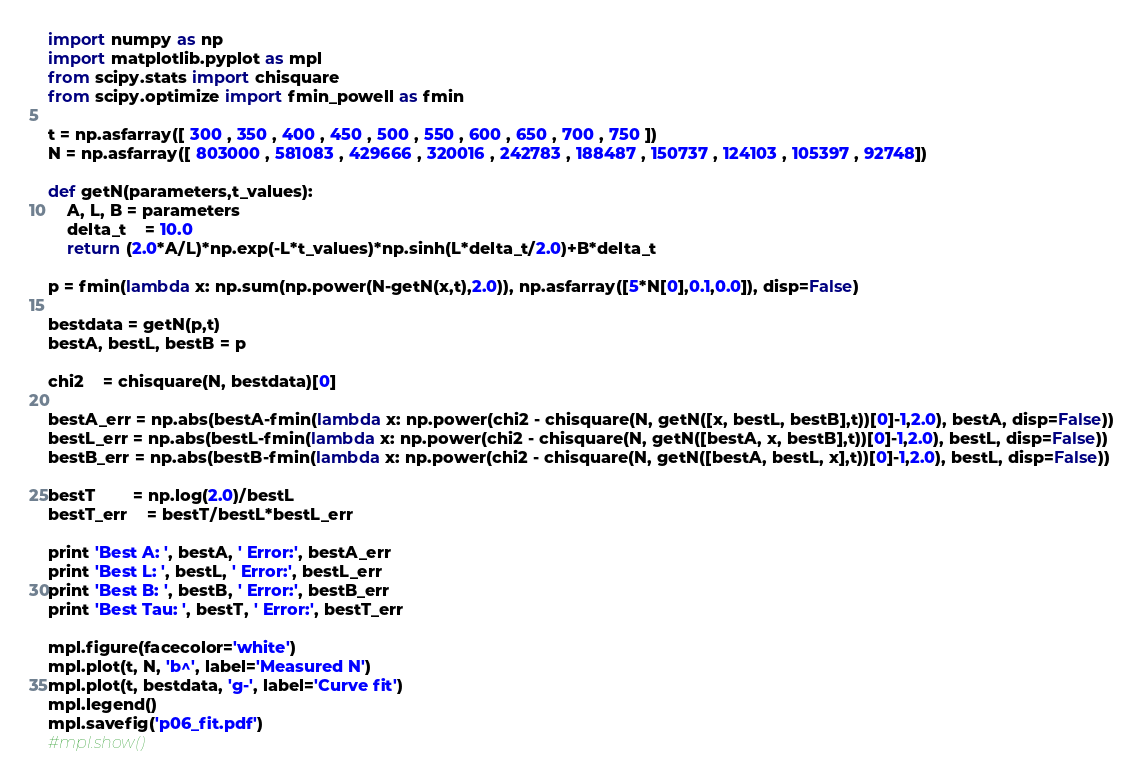<code> <loc_0><loc_0><loc_500><loc_500><_Python_>import numpy as np
import matplotlib.pyplot as mpl
from scipy.stats import chisquare
from scipy.optimize import fmin_powell as fmin

t = np.asfarray([ 300 , 350 , 400 , 450 , 500 , 550 , 600 , 650 , 700 , 750 ])
N = np.asfarray([ 803000 , 581083 , 429666 , 320016 , 242783 , 188487 , 150737 , 124103 , 105397 , 92748])

def getN(parameters,t_values):
	A, L, B = parameters
	delta_t	= 10.0
	return (2.0*A/L)*np.exp(-L*t_values)*np.sinh(L*delta_t/2.0)+B*delta_t

p = fmin(lambda x: np.sum(np.power(N-getN(x,t),2.0)), np.asfarray([5*N[0],0.1,0.0]), disp=False)

bestdata = getN(p,t)
bestA, bestL, bestB = p

chi2	= chisquare(N, bestdata)[0]

bestA_err = np.abs(bestA-fmin(lambda x: np.power(chi2 - chisquare(N, getN([x, bestL, bestB],t))[0]-1,2.0), bestA, disp=False))
bestL_err = np.abs(bestL-fmin(lambda x: np.power(chi2 - chisquare(N, getN([bestA, x, bestB],t))[0]-1,2.0), bestL, disp=False))
bestB_err = np.abs(bestB-fmin(lambda x: np.power(chi2 - chisquare(N, getN([bestA, bestL, x],t))[0]-1,2.0), bestL, disp=False))

bestT		= np.log(2.0)/bestL
bestT_err	= bestT/bestL*bestL_err

print 'Best A: ', bestA, ' Error:', bestA_err
print 'Best L: ', bestL, ' Error:', bestL_err
print 'Best B: ', bestB, ' Error:', bestB_err
print 'Best Tau: ', bestT, ' Error:', bestT_err

mpl.figure(facecolor='white')
mpl.plot(t, N, 'b^', label='Measured N')
mpl.plot(t, bestdata, 'g-', label='Curve fit')
mpl.legend()
mpl.savefig('p06_fit.pdf')
#mpl.show()</code> 